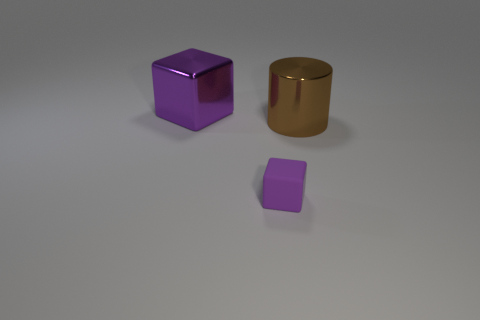Add 3 large purple metal things. How many objects exist? 6 Subtract all cylinders. How many objects are left? 2 Subtract 0 gray cylinders. How many objects are left? 3 Subtract all large gray cubes. Subtract all big metallic things. How many objects are left? 1 Add 2 small purple cubes. How many small purple cubes are left? 3 Add 3 large purple matte blocks. How many large purple matte blocks exist? 3 